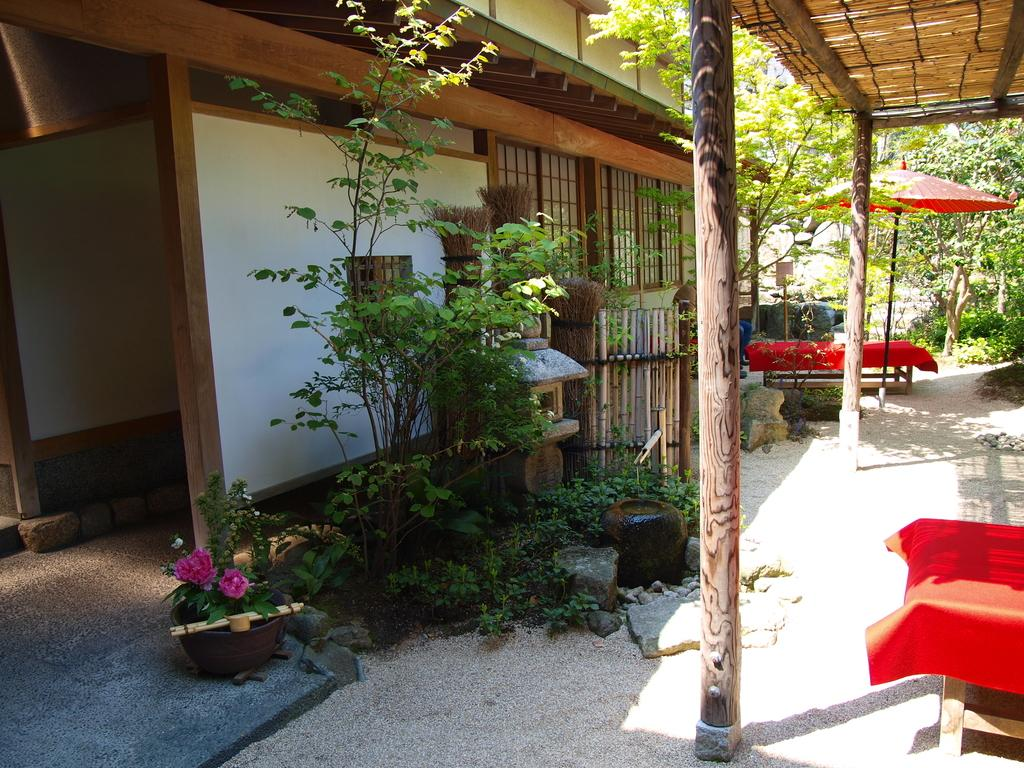Where was the image taken? The image was clicked outside. What can be seen in the middle of the image? There are plants in the middle of the image. What type of vegetation is on the right side of the image? There are trees on the right side of the image. What furniture is present in the bottom right corner of the image? There is a table in the bottom right corner of the image. What type of flora is present at the bottom of the image? There are flowers at the bottom of the image. What time is displayed on the clock in the image? There is no clock present in the image. 